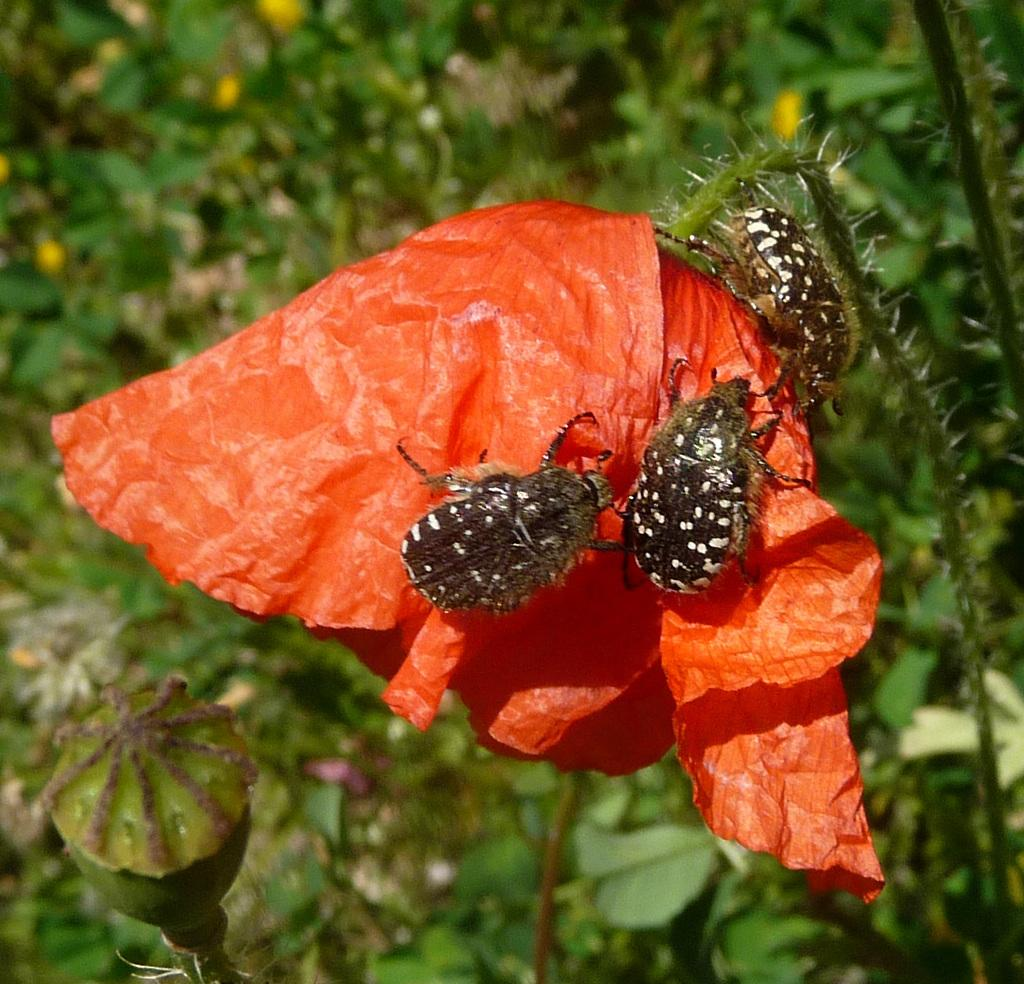What is happening on the flower in the image? There are insects on a flower in the image. What can be seen in the distance behind the flower? There are trees visible in the background of the image. How would you describe the overall clarity of the image? The image is blurry. What is the reason for the end of the expansion in the image? There is no reference to an end or expansion in the image, as it features insects on a flower and trees in the background. 